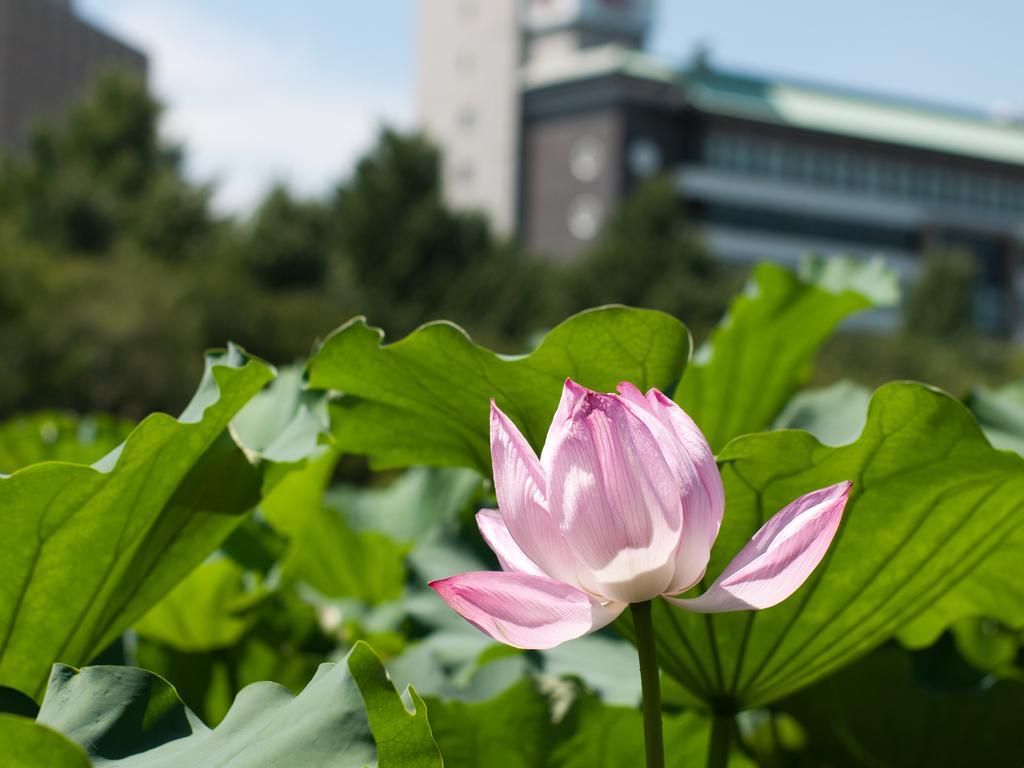Describe this image in one or two sentences. In this picture we can see a flower with the stem. Behind the flower there are leaves, trees, buildings and the sky. 